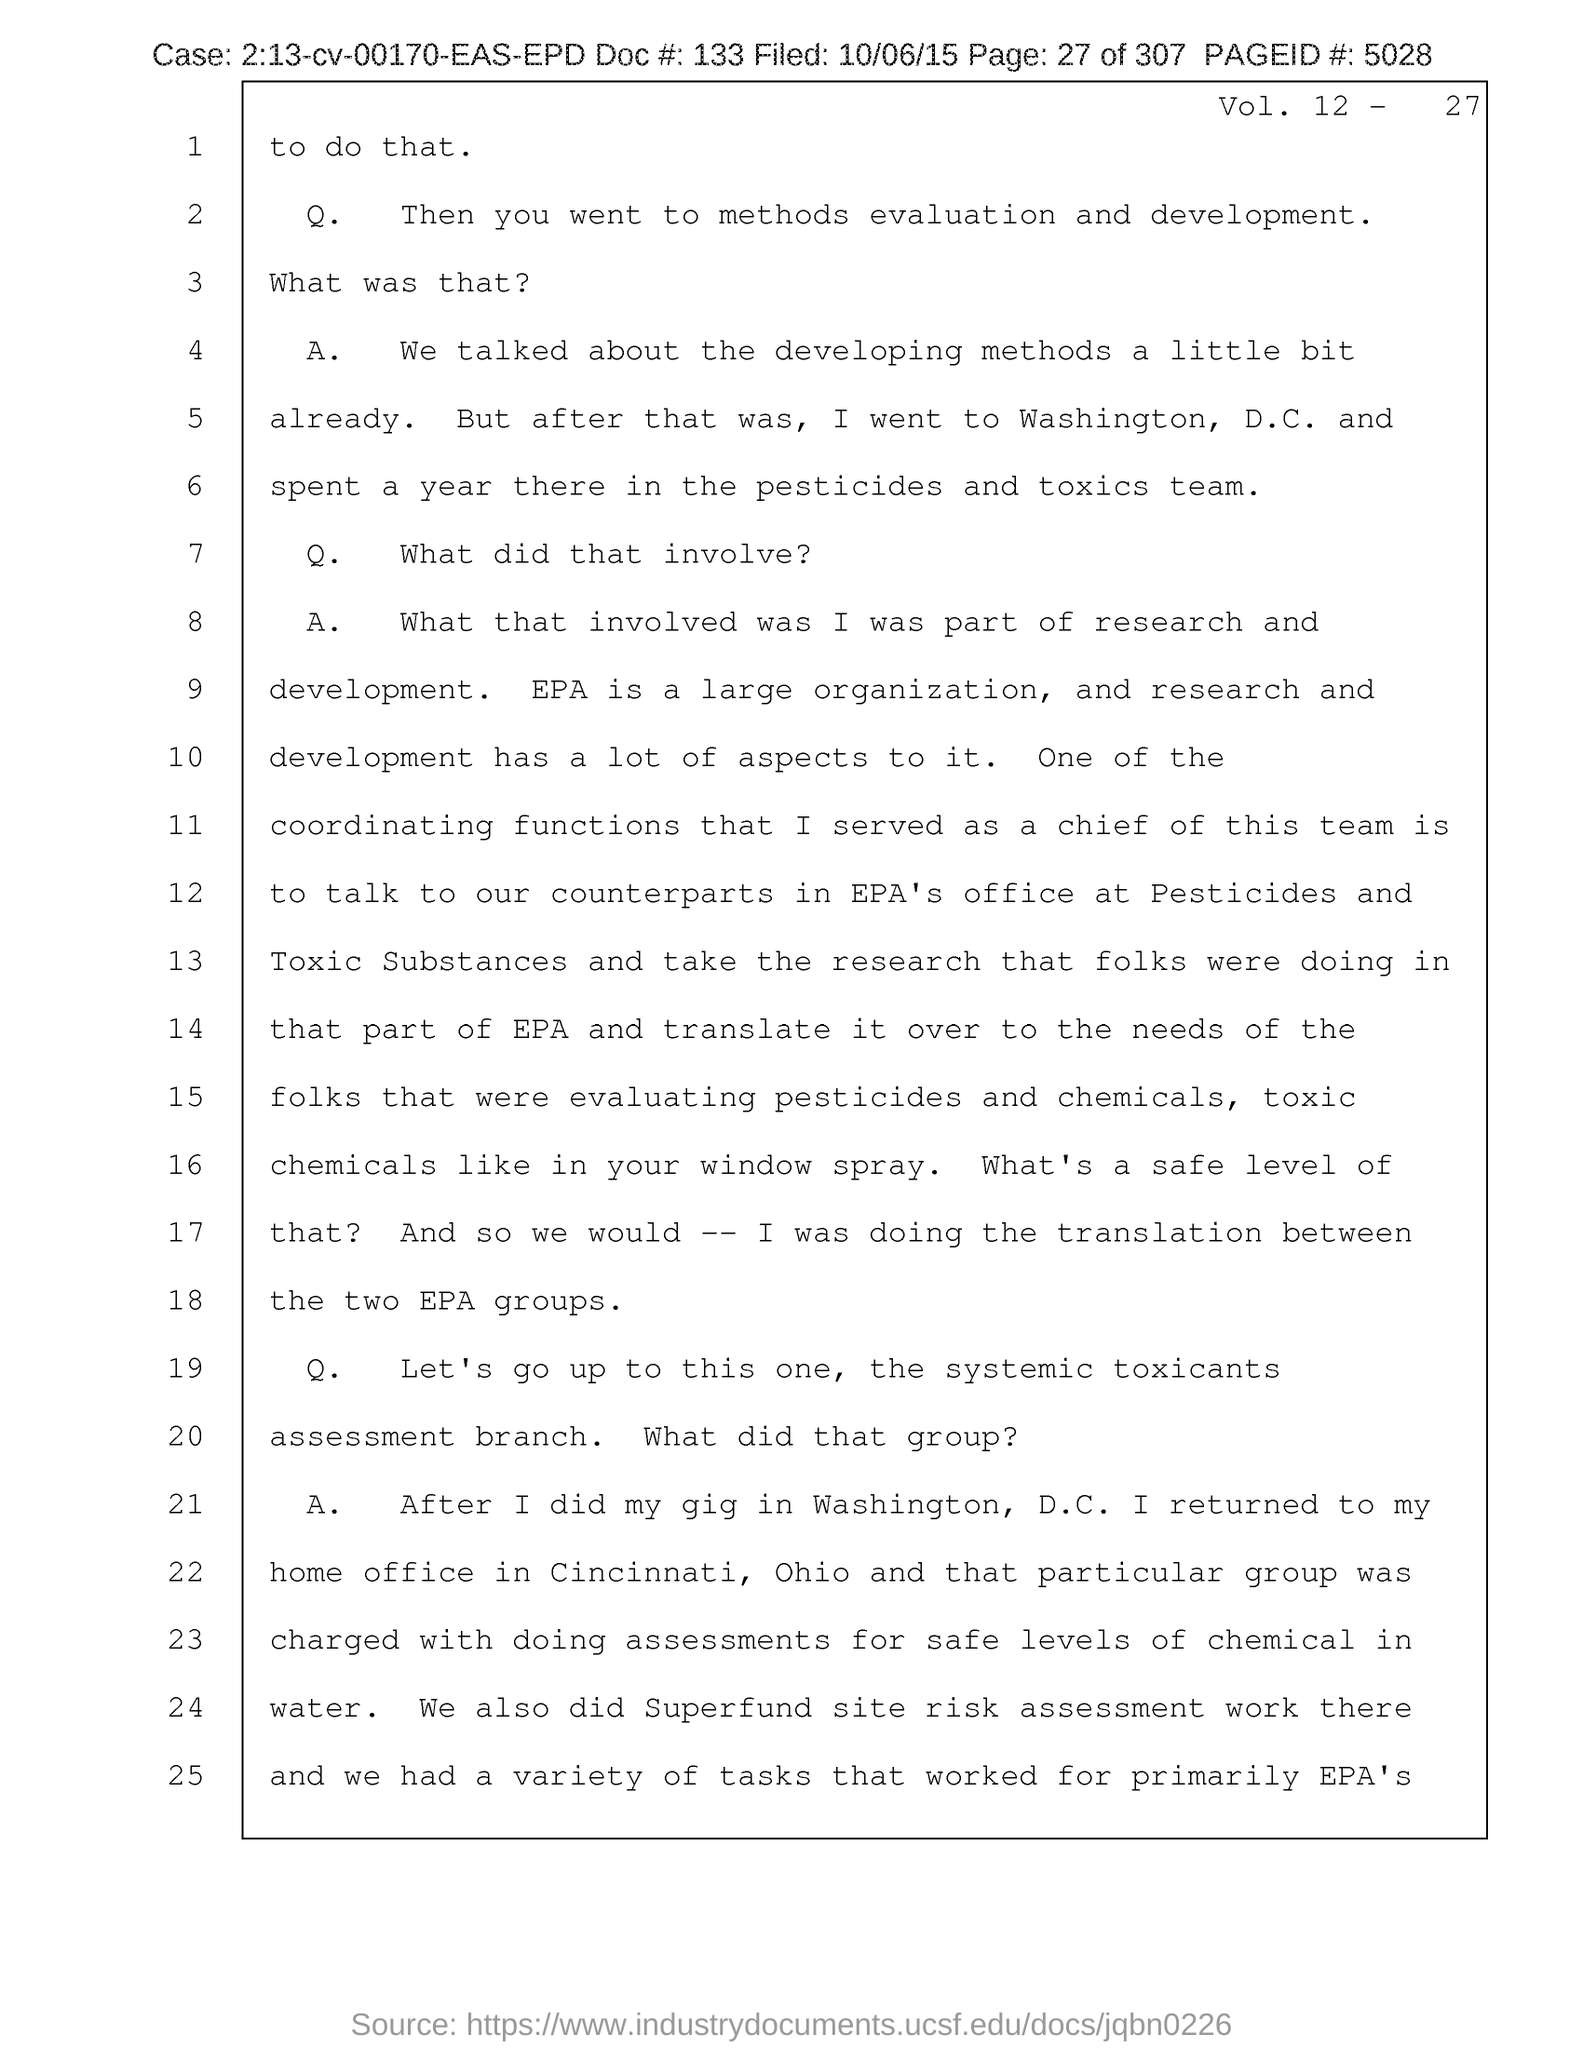List a handful of essential elements in this visual. The document provides a Vol. no. of 12... The provided document contains a reference to a document number, which is 133... The page number mentioned in this document is 27. The filed date of the document is October 6, 2015. The case number mentioned in the document is 2:13-cv-00170-EAS-EPD. 